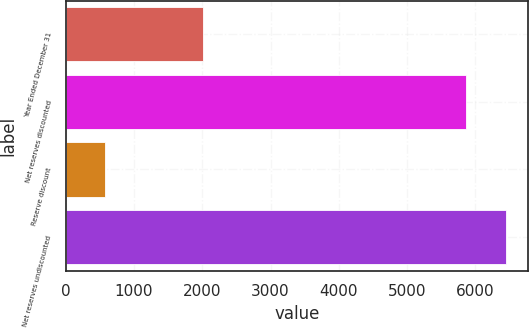Convert chart to OTSL. <chart><loc_0><loc_0><loc_500><loc_500><bar_chart><fcel>Year Ended December 31<fcel>Net reserves discounted<fcel>Reserve discount<fcel>Net reserves undiscounted<nl><fcel>2005<fcel>5867<fcel>575<fcel>6453.7<nl></chart> 